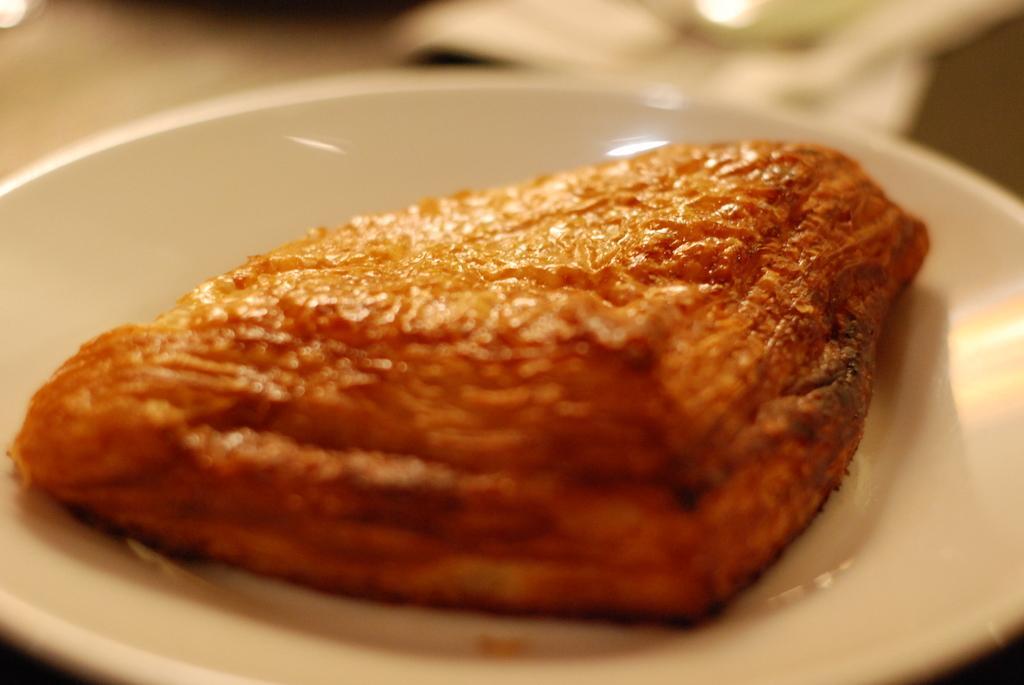Can you describe this image briefly? In this image we can see a serving plate which has a baked item in it. 